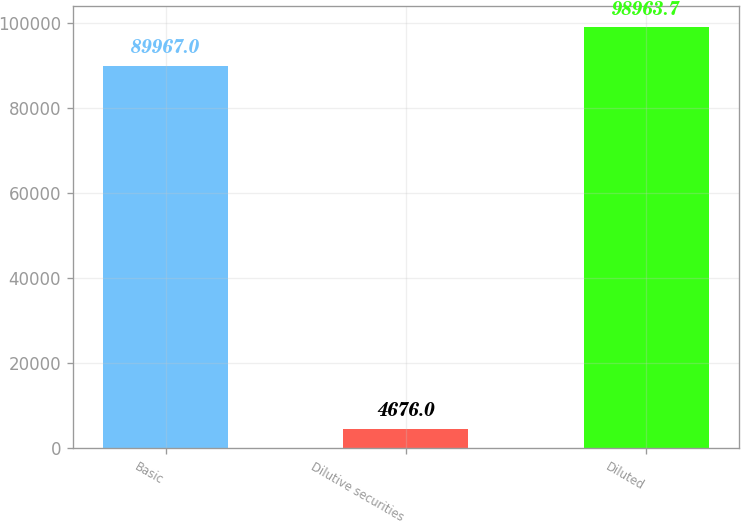<chart> <loc_0><loc_0><loc_500><loc_500><bar_chart><fcel>Basic<fcel>Dilutive securities<fcel>Diluted<nl><fcel>89967<fcel>4676<fcel>98963.7<nl></chart> 